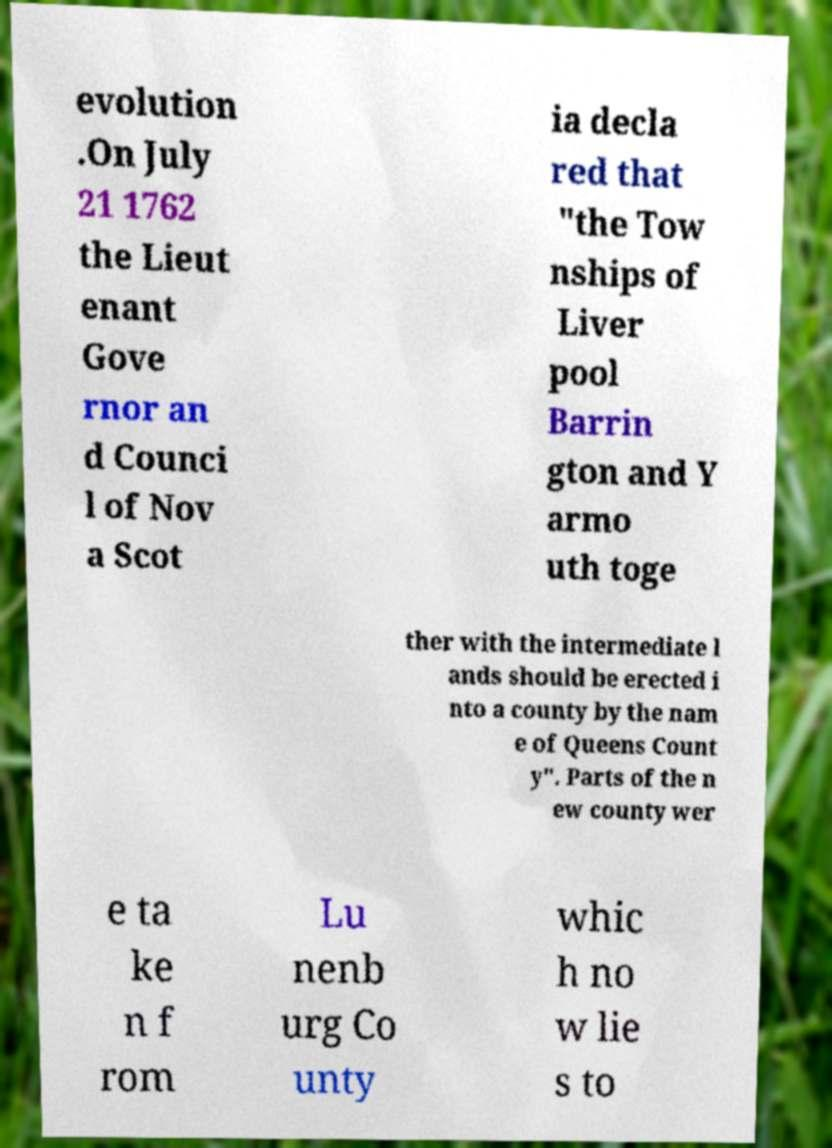I need the written content from this picture converted into text. Can you do that? evolution .On July 21 1762 the Lieut enant Gove rnor an d Counci l of Nov a Scot ia decla red that "the Tow nships of Liver pool Barrin gton and Y armo uth toge ther with the intermediate l ands should be erected i nto a county by the nam e of Queens Count y". Parts of the n ew county wer e ta ke n f rom Lu nenb urg Co unty whic h no w lie s to 